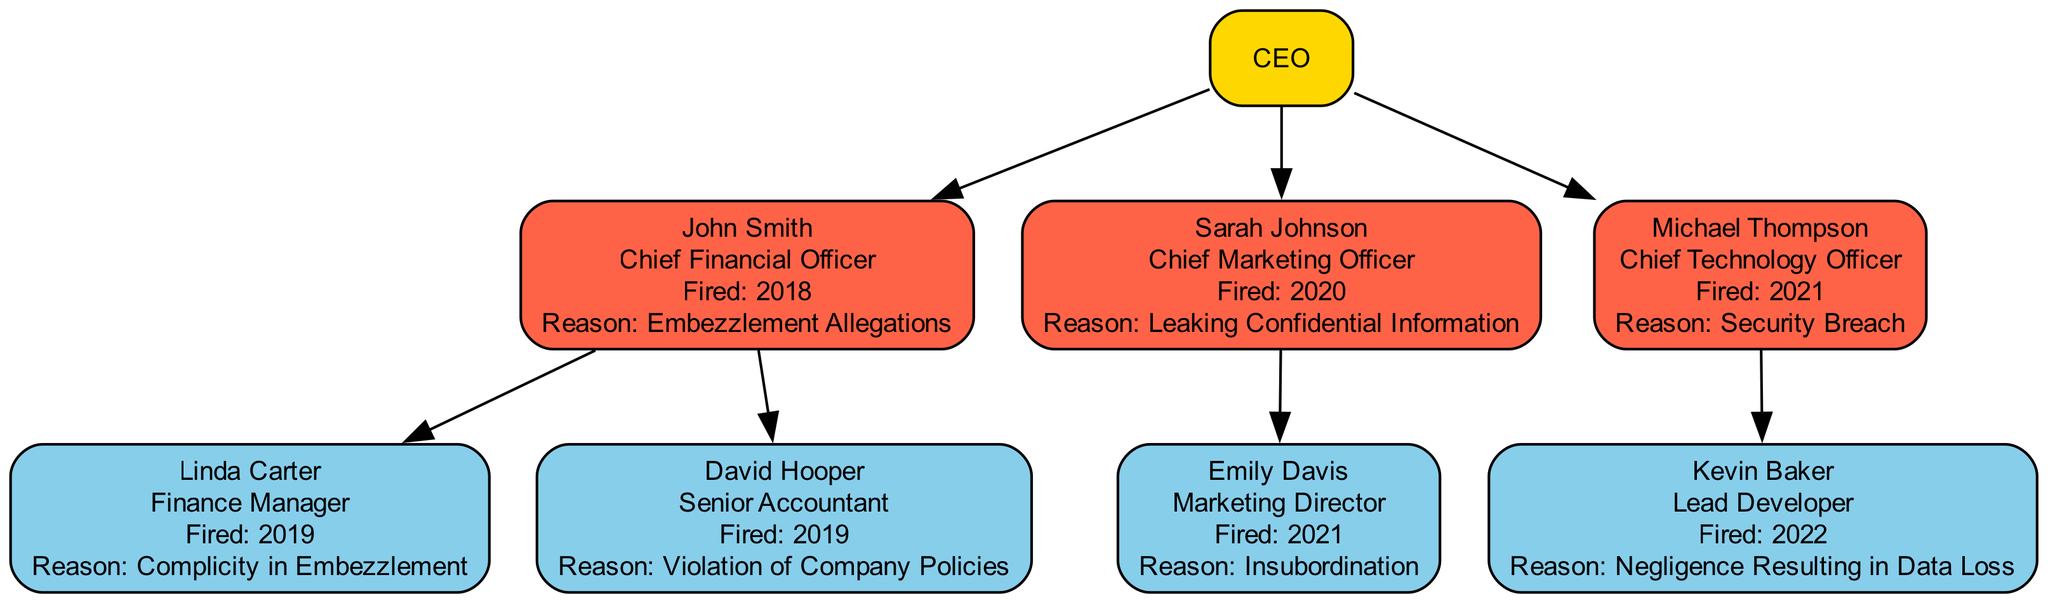What is the role of John Smith? The diagram indicates John Smith's role is listed next to his name, which shows he is the Chief Financial Officer.
Answer: Chief Financial Officer How many prominent employees were fired in total? By counting the main employees and their subordinates in the diagram, we find John Smith, Sarah Johnson, Michael Thompson, Linda Carter, David Hooper, Emily Davis, and Kevin Baker, totaling 7 employees.
Answer: 7 Who reported directly to the CEO and was fired in 2020? The diagram shows that Sarah Johnson reported directly to the CEO and was fired in 2020, as indicated in her details.
Answer: Sarah Johnson Which employee was responsible for a security breach? Examining the roles and reasons for termination, Michael Thompson was noted to have been fired for a security breach.
Answer: Michael Thompson What was the reason for Linda Carter's termination? Looking at Linda Carter's details in the diagram, it is stated that she was fired for complicity in embezzlement.
Answer: Complicity in Embezzlement Which subordinate reported directly to Michael Thompson? The diagram shows that Kevin Baker was the subordinate of Michael Thompson, as there is a direct edge connecting them in the hierarchy.
Answer: Kevin Baker What year was David Hooper fired? The diagram clearly shows that David Hooper was fired in 2019, identified in his node details.
Answer: 2019 How many subordinates did Sarah Johnson have? Counting the subordinate nodes attached to Sarah Johnson's node reveals that she had one subordinate, Emily Davis.
Answer: 1 What is the reason for Emily Davis's termination? The diagram specifies that Emily Davis was fired for insubordination, which is identified directly under her node in the diagram.
Answer: Insubordination 